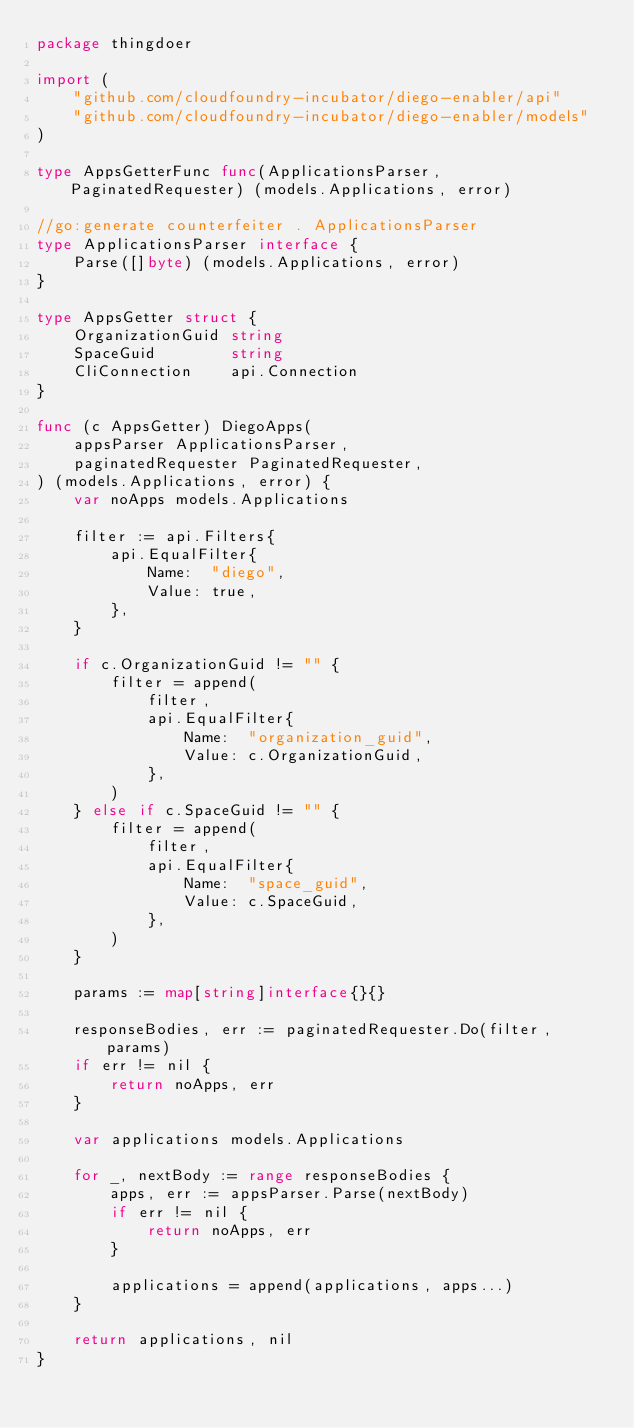Convert code to text. <code><loc_0><loc_0><loc_500><loc_500><_Go_>package thingdoer

import (
	"github.com/cloudfoundry-incubator/diego-enabler/api"
	"github.com/cloudfoundry-incubator/diego-enabler/models"
)

type AppsGetterFunc func(ApplicationsParser, PaginatedRequester) (models.Applications, error)

//go:generate counterfeiter . ApplicationsParser
type ApplicationsParser interface {
	Parse([]byte) (models.Applications, error)
}

type AppsGetter struct {
	OrganizationGuid string
	SpaceGuid        string
	CliConnection    api.Connection
}

func (c AppsGetter) DiegoApps(
	appsParser ApplicationsParser,
	paginatedRequester PaginatedRequester,
) (models.Applications, error) {
	var noApps models.Applications

	filter := api.Filters{
		api.EqualFilter{
			Name:  "diego",
			Value: true,
		},
	}

	if c.OrganizationGuid != "" {
		filter = append(
			filter,
			api.EqualFilter{
				Name:  "organization_guid",
				Value: c.OrganizationGuid,
			},
		)
	} else if c.SpaceGuid != "" {
		filter = append(
			filter,
			api.EqualFilter{
				Name:  "space_guid",
				Value: c.SpaceGuid,
			},
		)
	}

	params := map[string]interface{}{}

	responseBodies, err := paginatedRequester.Do(filter, params)
	if err != nil {
		return noApps, err
	}

	var applications models.Applications

	for _, nextBody := range responseBodies {
		apps, err := appsParser.Parse(nextBody)
		if err != nil {
			return noApps, err
		}

		applications = append(applications, apps...)
	}

	return applications, nil
}
</code> 